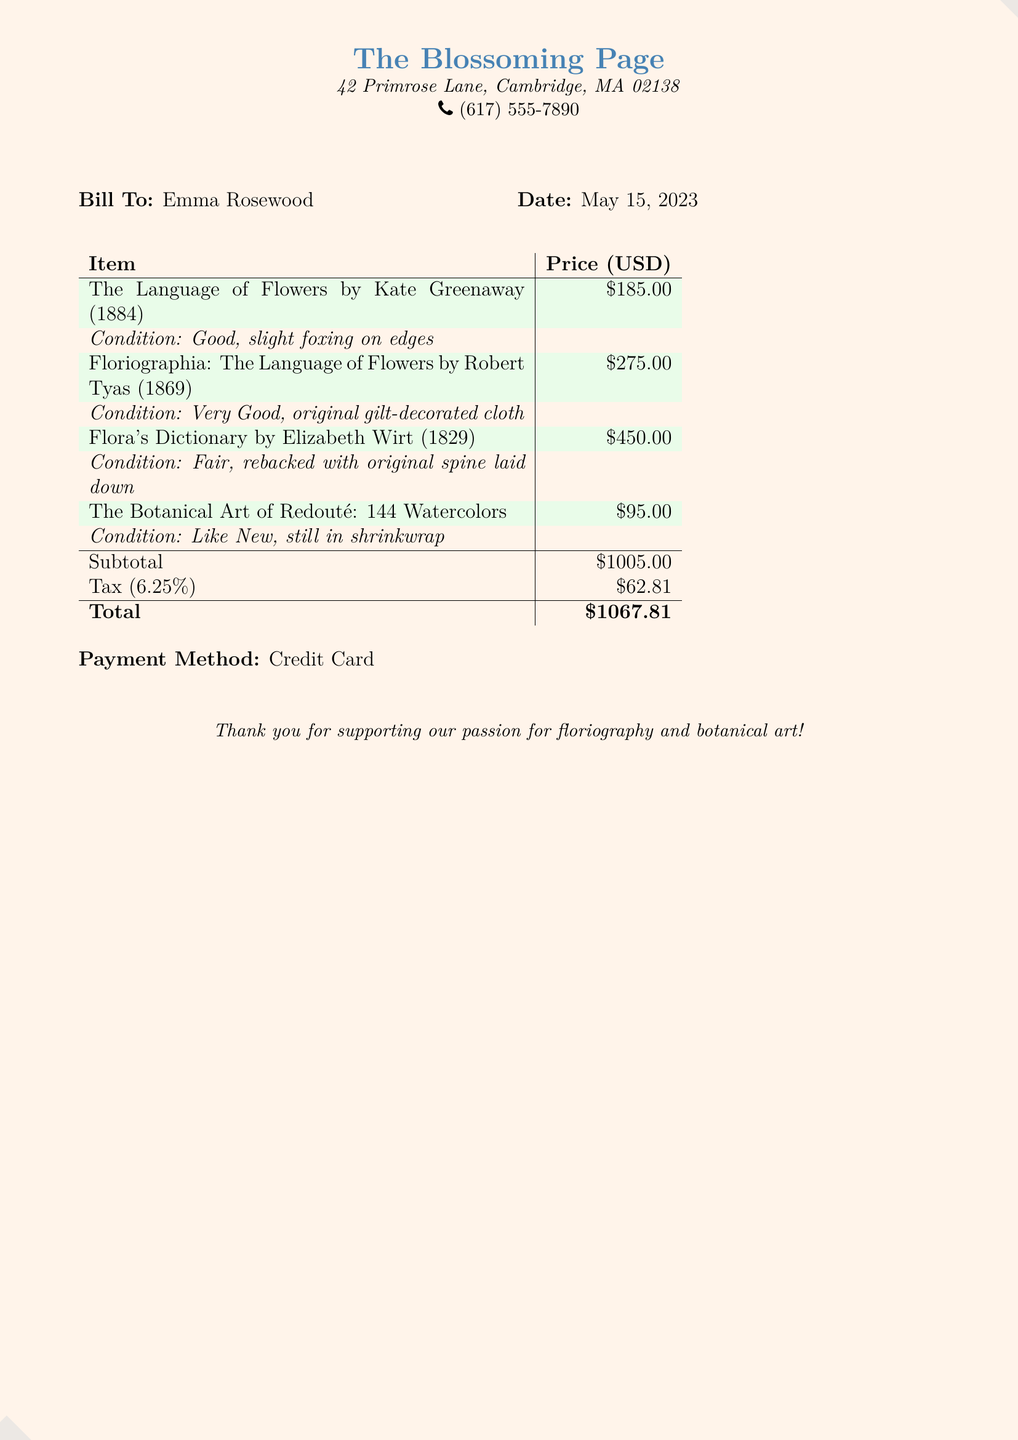What is the name of the bookshop? The document features a title at the top referencing "The Blossoming Page," which is the name of the bookshop.
Answer: The Blossoming Page Who is the bill addressed to? The document specifies the customer in the "Bill To" section, listing the name Emma Rosewood.
Answer: Emma Rosewood What is the date of the bill? The document includes a date which indicates when the transaction occurred, found in the "Date" section.
Answer: May 15, 2023 How much does "Flora's Dictionary" cost? The price for "Flora's Dictionary" is mentioned in the list of items, totaling $450.
Answer: $450.00 What is the total amount due? The total amount due is found at the bottom of the table, summing the subtotal and tax.
Answer: $1067.81 What is the condition of "The Botanical Art of Redouté"? The document specifies the condition of this book as "Like New, still in shrinkwrap."
Answer: Like New, still in shrinkwrap How much tax was applied to the transaction? The tax is clearly stated below the subtotal, calculated based on the listed tax rate.
Answer: $62.81 What method of payment was used? The document outlines the payment method used for this transaction in the "Payment Method" section.
Answer: Credit Card Which book is from 1884? The document lists items with their publication years, identifying "The Language of Flowers" as the title from 1884.
Answer: The Language of Flowers by Kate Greenaway (1884) 